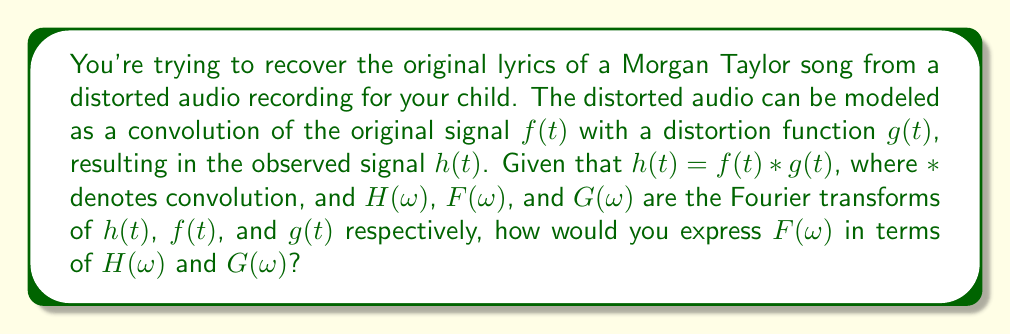Help me with this question. To solve this inverse problem and recover the original lyrics, we need to follow these steps:

1) Recall the convolution theorem, which states that the Fourier transform of a convolution is the product of the Fourier transforms:

   $\mathcal{F}\{f(t) * g(t)\} = F(\omega) \cdot G(\omega)$

2) Given that $h(t) = f(t) * g(t)$, we can apply the convolution theorem:

   $H(\omega) = F(\omega) \cdot G(\omega)$

3) To isolate $F(\omega)$, we need to divide both sides by $G(\omega)$:

   $\frac{H(\omega)}{G(\omega)} = F(\omega)$

4) However, we need to be cautious about dividing by $G(\omega)$ as it might be zero for some frequencies. In practice, we would use regularization techniques to handle this issue.

5) The expression $F(\omega) = \frac{H(\omega)}{G(\omega)}$ gives us the Fourier transform of the original signal. To get back to the time domain (and thus the original lyrics), we would need to apply the inverse Fourier transform:

   $f(t) = \mathcal{F}^{-1}\{\frac{H(\omega)}{G(\omega)}\}$

This process is known as deconvolution in the frequency domain.
Answer: $F(\omega) = \frac{H(\omega)}{G(\omega)}$ 